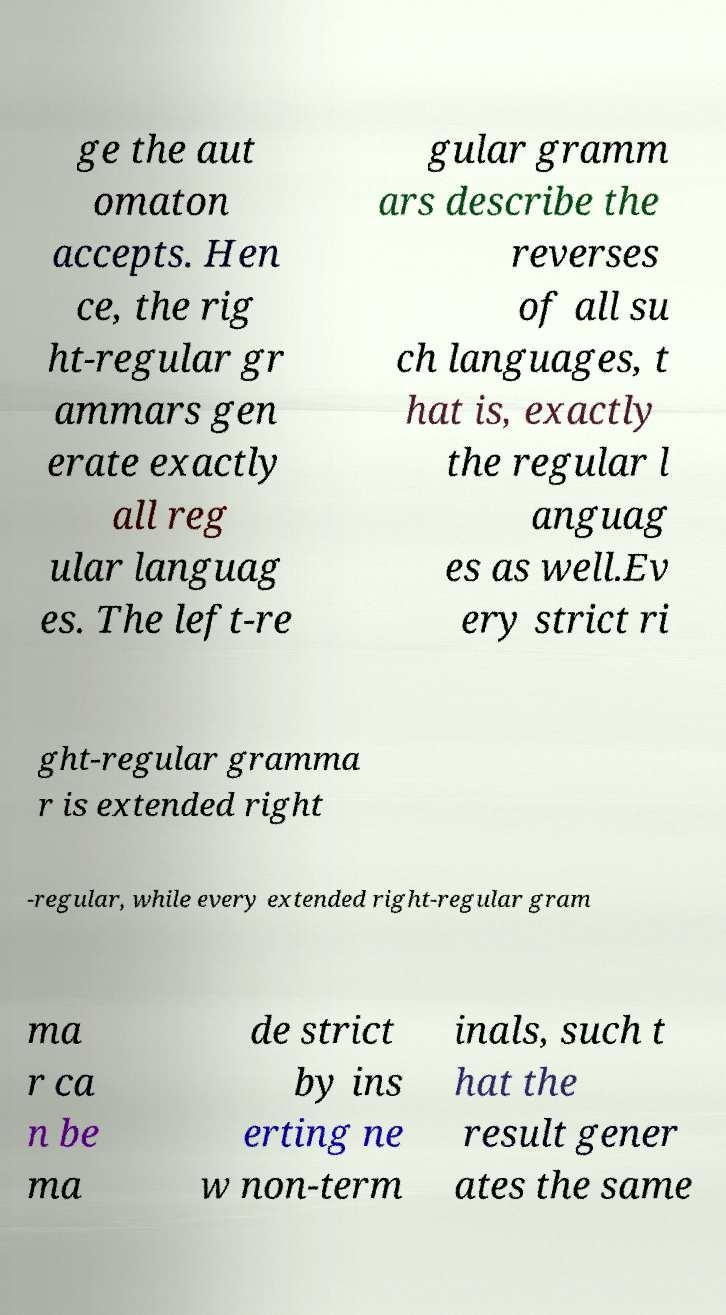Could you assist in decoding the text presented in this image and type it out clearly? ge the aut omaton accepts. Hen ce, the rig ht-regular gr ammars gen erate exactly all reg ular languag es. The left-re gular gramm ars describe the reverses of all su ch languages, t hat is, exactly the regular l anguag es as well.Ev ery strict ri ght-regular gramma r is extended right -regular, while every extended right-regular gram ma r ca n be ma de strict by ins erting ne w non-term inals, such t hat the result gener ates the same 